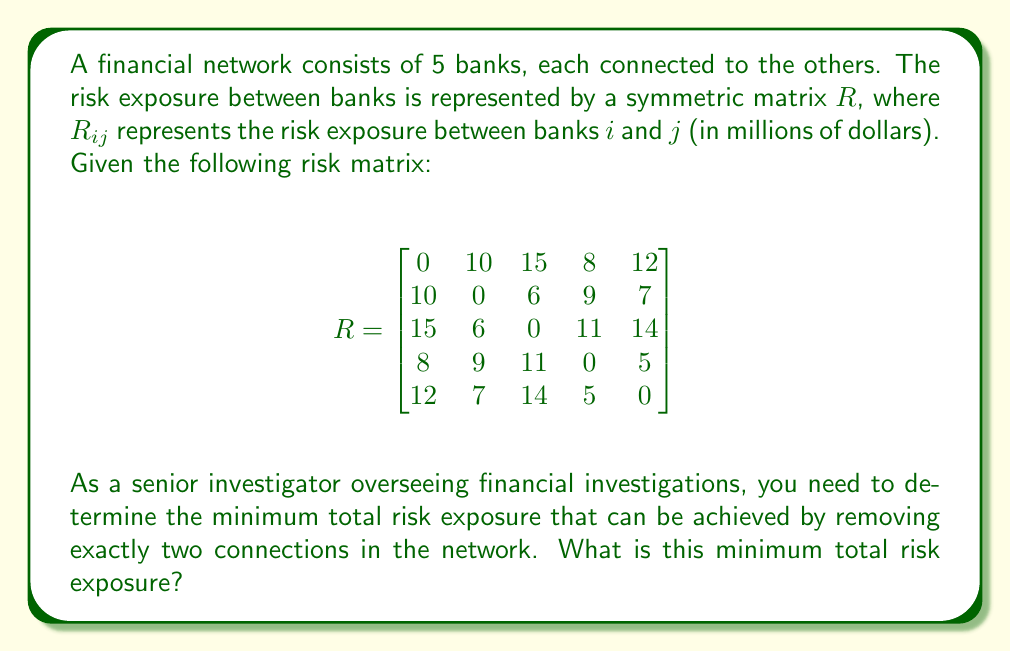Could you help me with this problem? To solve this problem, we need to follow these steps:

1. Calculate the total risk exposure of the initial network.
2. Identify all possible combinations of two connections that can be removed.
3. Calculate the total risk exposure for each combination after removal.
4. Find the minimum total risk exposure among all combinations.

Step 1: Calculate the initial total risk exposure
The total risk exposure is the sum of all elements in the upper (or lower) triangle of the matrix, as the matrix is symmetric.

Initial total risk exposure = $(10 + 15 + 8 + 12 + 6 + 9 + 7 + 11 + 14 + 5) = 97$ million dollars

Step 2: Identify all possible combinations
There are $\binom{10}{2} = 45$ possible combinations of two connections that can be removed.

Step 3: Calculate the total risk exposure for each combination
For each combination, we need to subtract the sum of the two removed connections from the initial total risk exposure.

Step 4: Find the minimum total risk exposure
After calculating all combinations, we find that the minimum total risk exposure is achieved by removing the connections between banks 1 and 3 (15 million) and banks 3 and 5 (14 million).

Minimum total risk exposure = $97 - (15 + 14) = 68$ million dollars

This combination minimizes the risk exposure by removing the two highest-risk connections in the network.
Answer: The minimum total risk exposure that can be achieved by removing exactly two connections in the network is $68$ million dollars. 